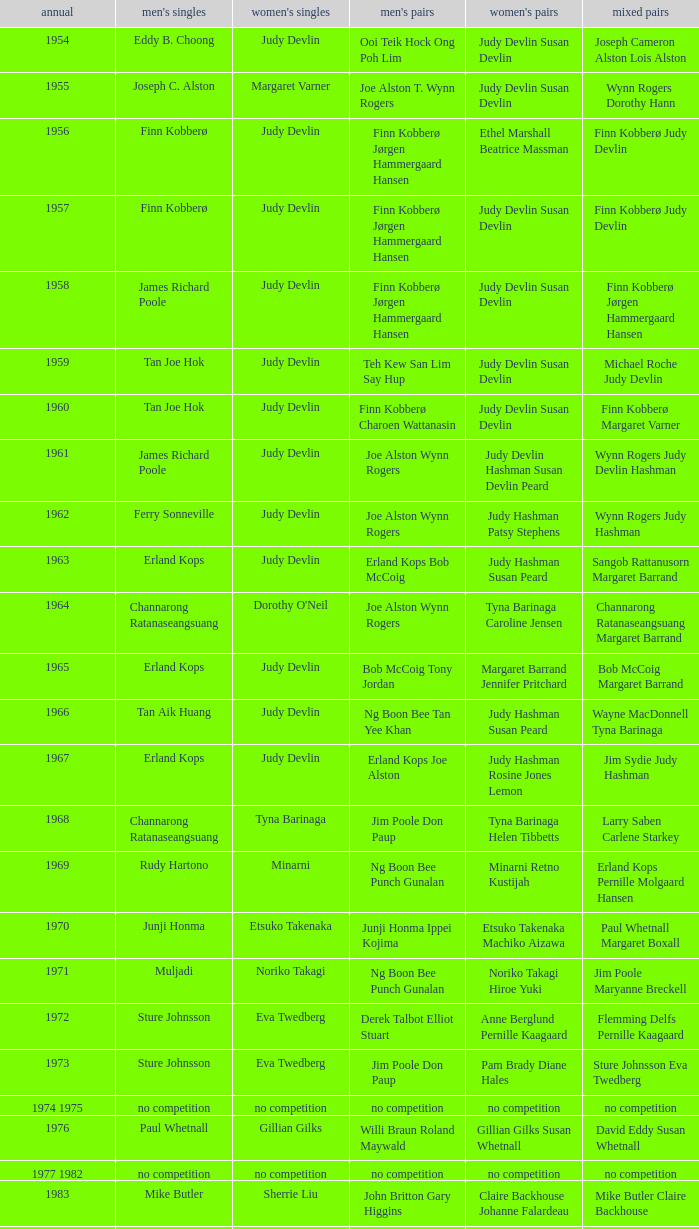Who were the men's doubles champions when the men's singles champion was muljadi? Ng Boon Bee Punch Gunalan. Could you parse the entire table as a dict? {'header': ['annual', "men's singles", "women's singles", "men's pairs", "women's pairs", 'mixed pairs'], 'rows': [['1954', 'Eddy B. Choong', 'Judy Devlin', 'Ooi Teik Hock Ong Poh Lim', 'Judy Devlin Susan Devlin', 'Joseph Cameron Alston Lois Alston'], ['1955', 'Joseph C. Alston', 'Margaret Varner', 'Joe Alston T. Wynn Rogers', 'Judy Devlin Susan Devlin', 'Wynn Rogers Dorothy Hann'], ['1956', 'Finn Kobberø', 'Judy Devlin', 'Finn Kobberø Jørgen Hammergaard Hansen', 'Ethel Marshall Beatrice Massman', 'Finn Kobberø Judy Devlin'], ['1957', 'Finn Kobberø', 'Judy Devlin', 'Finn Kobberø Jørgen Hammergaard Hansen', 'Judy Devlin Susan Devlin', 'Finn Kobberø Judy Devlin'], ['1958', 'James Richard Poole', 'Judy Devlin', 'Finn Kobberø Jørgen Hammergaard Hansen', 'Judy Devlin Susan Devlin', 'Finn Kobberø Jørgen Hammergaard Hansen'], ['1959', 'Tan Joe Hok', 'Judy Devlin', 'Teh Kew San Lim Say Hup', 'Judy Devlin Susan Devlin', 'Michael Roche Judy Devlin'], ['1960', 'Tan Joe Hok', 'Judy Devlin', 'Finn Kobberø Charoen Wattanasin', 'Judy Devlin Susan Devlin', 'Finn Kobberø Margaret Varner'], ['1961', 'James Richard Poole', 'Judy Devlin', 'Joe Alston Wynn Rogers', 'Judy Devlin Hashman Susan Devlin Peard', 'Wynn Rogers Judy Devlin Hashman'], ['1962', 'Ferry Sonneville', 'Judy Devlin', 'Joe Alston Wynn Rogers', 'Judy Hashman Patsy Stephens', 'Wynn Rogers Judy Hashman'], ['1963', 'Erland Kops', 'Judy Devlin', 'Erland Kops Bob McCoig', 'Judy Hashman Susan Peard', 'Sangob Rattanusorn Margaret Barrand'], ['1964', 'Channarong Ratanaseangsuang', "Dorothy O'Neil", 'Joe Alston Wynn Rogers', 'Tyna Barinaga Caroline Jensen', 'Channarong Ratanaseangsuang Margaret Barrand'], ['1965', 'Erland Kops', 'Judy Devlin', 'Bob McCoig Tony Jordan', 'Margaret Barrand Jennifer Pritchard', 'Bob McCoig Margaret Barrand'], ['1966', 'Tan Aik Huang', 'Judy Devlin', 'Ng Boon Bee Tan Yee Khan', 'Judy Hashman Susan Peard', 'Wayne MacDonnell Tyna Barinaga'], ['1967', 'Erland Kops', 'Judy Devlin', 'Erland Kops Joe Alston', 'Judy Hashman Rosine Jones Lemon', 'Jim Sydie Judy Hashman'], ['1968', 'Channarong Ratanaseangsuang', 'Tyna Barinaga', 'Jim Poole Don Paup', 'Tyna Barinaga Helen Tibbetts', 'Larry Saben Carlene Starkey'], ['1969', 'Rudy Hartono', 'Minarni', 'Ng Boon Bee Punch Gunalan', 'Minarni Retno Kustijah', 'Erland Kops Pernille Molgaard Hansen'], ['1970', 'Junji Honma', 'Etsuko Takenaka', 'Junji Honma Ippei Kojima', 'Etsuko Takenaka Machiko Aizawa', 'Paul Whetnall Margaret Boxall'], ['1971', 'Muljadi', 'Noriko Takagi', 'Ng Boon Bee Punch Gunalan', 'Noriko Takagi Hiroe Yuki', 'Jim Poole Maryanne Breckell'], ['1972', 'Sture Johnsson', 'Eva Twedberg', 'Derek Talbot Elliot Stuart', 'Anne Berglund Pernille Kaagaard', 'Flemming Delfs Pernille Kaagaard'], ['1973', 'Sture Johnsson', 'Eva Twedberg', 'Jim Poole Don Paup', 'Pam Brady Diane Hales', 'Sture Johnsson Eva Twedberg'], ['1974 1975', 'no competition', 'no competition', 'no competition', 'no competition', 'no competition'], ['1976', 'Paul Whetnall', 'Gillian Gilks', 'Willi Braun Roland Maywald', 'Gillian Gilks Susan Whetnall', 'David Eddy Susan Whetnall'], ['1977 1982', 'no competition', 'no competition', 'no competition', 'no competition', 'no competition'], ['1983', 'Mike Butler', 'Sherrie Liu', 'John Britton Gary Higgins', 'Claire Backhouse Johanne Falardeau', 'Mike Butler Claire Backhouse'], ['1984', 'Xiong Guobao', 'Luo Yun', 'Chen Hongyong Zhang Qingwu', 'Yin Haichen Lu Yanahua', 'Wang Pengren Luo Yun'], ['1985', 'Mike Butler', 'Claire Backhouse Sharpe', 'John Britton Gary Higgins', 'Claire Sharpe Sandra Skillings', 'Mike Butler Claire Sharpe'], ['1986', 'Sung Han-kuk', 'Denyse Julien', 'Yao Ximing Tariq Wadood', 'Denyse Julien Johanne Falardeau', 'Mike Butler Johanne Falardeau'], ['1987', 'Park Sun-bae', 'Chun Suk-sun', 'Lee Deuk-choon Lee Sang-bok', 'Kim Ho Ja Chung So-young', 'Lee Deuk-choon Chung So-young'], ['1988', 'Sze Yu', 'Lee Myeong-hee', 'Christian Hadinata Lius Pongoh', 'Kim Ho Ja Chung So-young', 'Christian Hadinata Ivana Lie'], ['1989', 'no competition', 'no competition', 'no competition', 'no competition', 'no competition'], ['1990', 'Fung Permadi', 'Denyse Julien', 'Ger Shin-Ming Yang Shih-Jeng', 'Denyse Julien Doris Piché', 'Tariq Wadood Traci Britton'], ['1991', 'Steve Butler', 'Shim Eun-jung', 'Jalani Sidek Razif Sidek', 'Shim Eun-jung Kang Bok-seung', 'Lee Sang-bok Shim Eun-jung'], ['1992', 'Poul-Erik Hoyer-Larsen', 'Lim Xiaoqing', 'Cheah Soon Kit Soo Beng Kiang', 'Lim Xiaoqing Christine Magnusson', 'Thomas Lund Pernille Dupont'], ['1993', 'Marleve Mainaky', 'Lim Xiaoqing', 'Thomas Lund Jon Holst-Christensen', 'Gil Young-ah Chung So-young', 'Thomas Lund Catrine Bengtsson'], ['1994', 'Thomas Stuer-Lauridsen', 'Liu Guimei', 'Ade Sutrisna Candra Wijaya', 'Rikke Olsen Helene Kirkegaard', 'Jens Eriksen Rikke Olsen'], ['1995', 'Hermawan Susanto', 'Ye Zhaoying', 'Rudy Gunawan Joko Suprianto', 'Gil Young-ah Jang Hye-ock', 'Kim Dong-moon Gil Young-ah'], ['1996', 'Joko Suprianto', 'Mia Audina', 'Candra Wijaya Sigit Budiarto', 'Zelin Resiana Eliza Nathanael', 'Kim Dong-moon Chung So-young'], ['1997', 'Poul-Erik Hoyer-Larsen', 'Camilla Martin', 'Ha Tae-kwon Kim Dong-moon', 'Qin Yiyuan Tang Yongshu', 'Kim Dong Moon Ra Kyung-min'], ['1998', 'Fung Permadi', 'Tang Yeping', 'Horng Shin-Jeng Lee Wei-Jen', 'Elinor Middlemiss Kirsteen McEwan', 'Kenny Middlemiss Elinor Middlemiss'], ['1999', 'Colin Haughton', 'Pi Hongyan', 'Michael Lamp Jonas Rasmussen', 'Huang Nanyan Lu Ying', 'Jonas Rasmussen Jane F. Bramsen'], ['2000', 'Ardy Wiranata', 'Choi Ma-re', 'Graham Hurrell James Anderson', 'Gail Emms Joanne Wright', 'Jonas Rasmussen Jane F. Bramsen'], ['2001', 'Lee Hyun-il', 'Ra Kyung-min', 'Kang Kyung-jin Park Young-duk', 'Kim Kyeung-ran Ra Kyung-min', 'Mathias Boe Majken Vange'], ['2002', 'Peter Gade', 'Julia Mann', 'Tony Gunawan Khan Malaythong', 'Joanne Wright Natalie Munt', 'Tony Gunawan Etty Tantri'], ['2003', 'Chien Yu-hsiu', 'Kelly Morgan', 'Tony Gunawan Khan Malaythong', 'Yoshiko Iwata Miyuki Tai', 'Tony Gunawan Eti Gunawan'], ['2004', 'Kendrick Lee Yen Hui', 'Xing Aiying', 'Howard Bach Tony Gunawan', 'Cheng Wen-hsing Chien Yu-chin', 'Lin Wei-hsiang Cheng Wen-hsing'], ['2005', 'Hsieh Yu-hsing', 'Lili Zhou', 'Howard Bach Tony Gunawan', 'Peng Yun Johanna Lee', 'Khan Malaythong Mesinee Mangkalakiri'], ['2006', 'Yousuke Nakanishi', 'Ella Karachkova', 'Halim Haryanto Tony Gunawan', 'Nina Vislova Valeria Sorokina', 'Sergey Ivlev Nina Vislova'], ['2007', 'Lee Tsuen Seng', 'Jun Jae-youn', 'Tadashi Ohtsuka Keita Masuda', 'Miyuki Maeda Satoko Suetsuna', 'Keita Masuda Miyuki Maeda'], ['2008', 'Andrew Dabeka', 'Lili Zhou', 'Howard Bach Khan Malaythong', 'Chang Li-Ying Hung Shih-Chieh', 'Halim Haryanto Peng Yun'], ['2009', 'Taufik Hidayat', 'Anna Rice', 'Howard Bach Tony Gunawan', 'Ruilin Huang Xuelian Jiang', 'Howard Bach Eva Lee'], ['2010', 'Rajiv Ouseph', 'Zhu Lin', 'Fang Chieh-min Lee Sheng-mu', 'Cheng Wen-hsing Chien Yu-chin', 'Michael Fuchs Birgit Overzier'], ['2011', 'Sho Sasaki', 'Tai Tzu-ying', 'Ko Sung-hyun Lee Yong-dae', 'Ha Jung-eun Kim Min-jung', 'Lee Yong-dae Ha Jung-eun'], ['2012', 'Vladimir Ivanov', 'Pai Hsiao-ma', 'Hiroyuki Endo Kenichi Hayakawa', 'Misaki Matsutomo Ayaka Takahashi', 'Tony Gunawan Vita Marissa'], ['2013', 'Nguyen Tien Minh', 'Sapsiree Taerattanachai', 'Takeshi Kamura Keigo Sonoda', 'Bao Yixin Zhong Qianxin', 'Lee Chun Hei Chau Hoi Wah']]} 